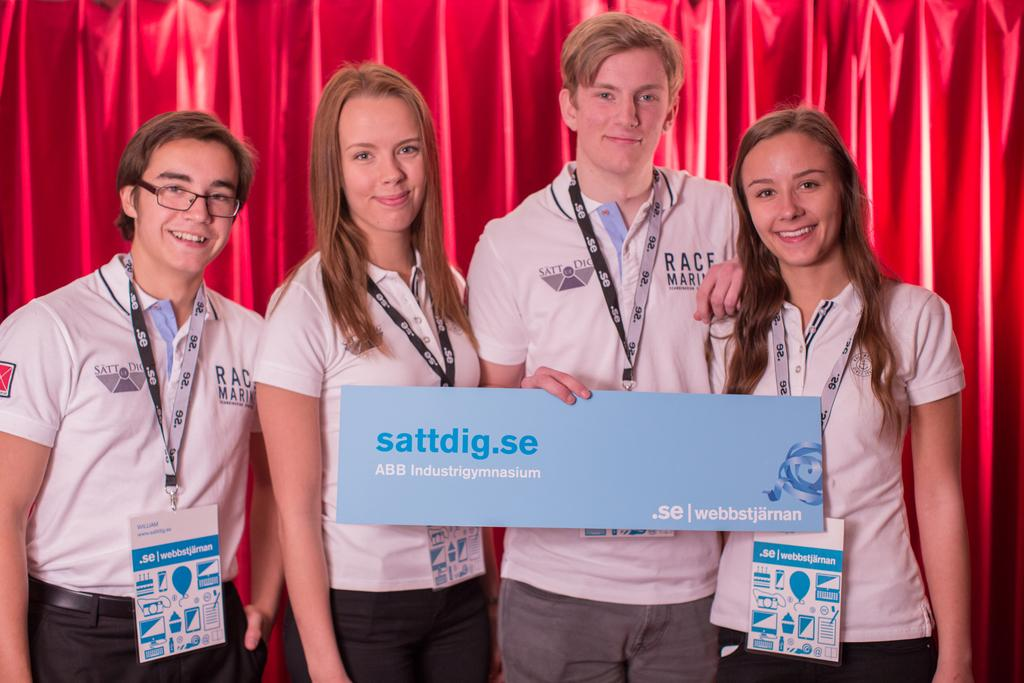How many people are present in the image? There are four people in the image. What are the people wearing? The people are wearing white t-shirts. What is one person doing in the image? One person is holding a banner. What can be seen in the background of the image? There are curtains visible in the background. Reasoning: Let' Let's think step by step in order to produce the conversation. We start by identifying the number of people in the image, which is four. Then, we describe what they are wearing, which is white t-shirts. Next, we focus on one person's action, which is holding a banner. Finally, we mention the background elements, which include curtains. Absurd Question/Answer: What type of joke is being told by the person holding the banner in the image? There is no indication of a joke being told in the image; the person is simply holding a banner. How many cakes are visible on the table in the image? There is no table or cakes present in the image. What type of quartz can be seen in the image? There is no quartz present in the image. 